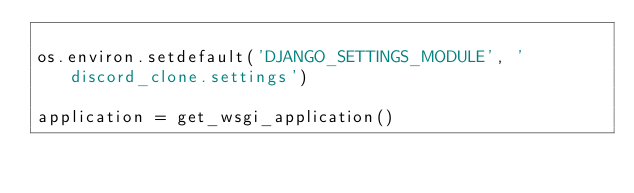<code> <loc_0><loc_0><loc_500><loc_500><_Python_>
os.environ.setdefault('DJANGO_SETTINGS_MODULE', 'discord_clone.settings')

application = get_wsgi_application()
</code> 